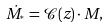Convert formula to latex. <formula><loc_0><loc_0><loc_500><loc_500>\dot { M } _ { ^ { * } } = \mathcal { C } ( z ) \cdot M ,</formula> 